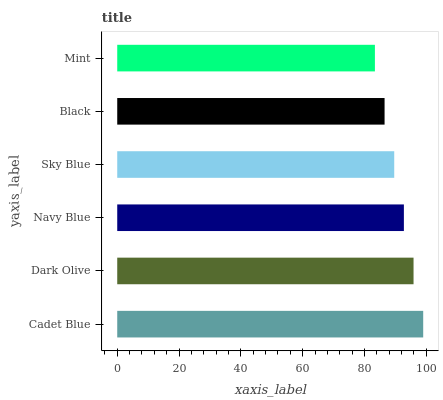Is Mint the minimum?
Answer yes or no. Yes. Is Cadet Blue the maximum?
Answer yes or no. Yes. Is Dark Olive the minimum?
Answer yes or no. No. Is Dark Olive the maximum?
Answer yes or no. No. Is Cadet Blue greater than Dark Olive?
Answer yes or no. Yes. Is Dark Olive less than Cadet Blue?
Answer yes or no. Yes. Is Dark Olive greater than Cadet Blue?
Answer yes or no. No. Is Cadet Blue less than Dark Olive?
Answer yes or no. No. Is Navy Blue the high median?
Answer yes or no. Yes. Is Sky Blue the low median?
Answer yes or no. Yes. Is Black the high median?
Answer yes or no. No. Is Black the low median?
Answer yes or no. No. 